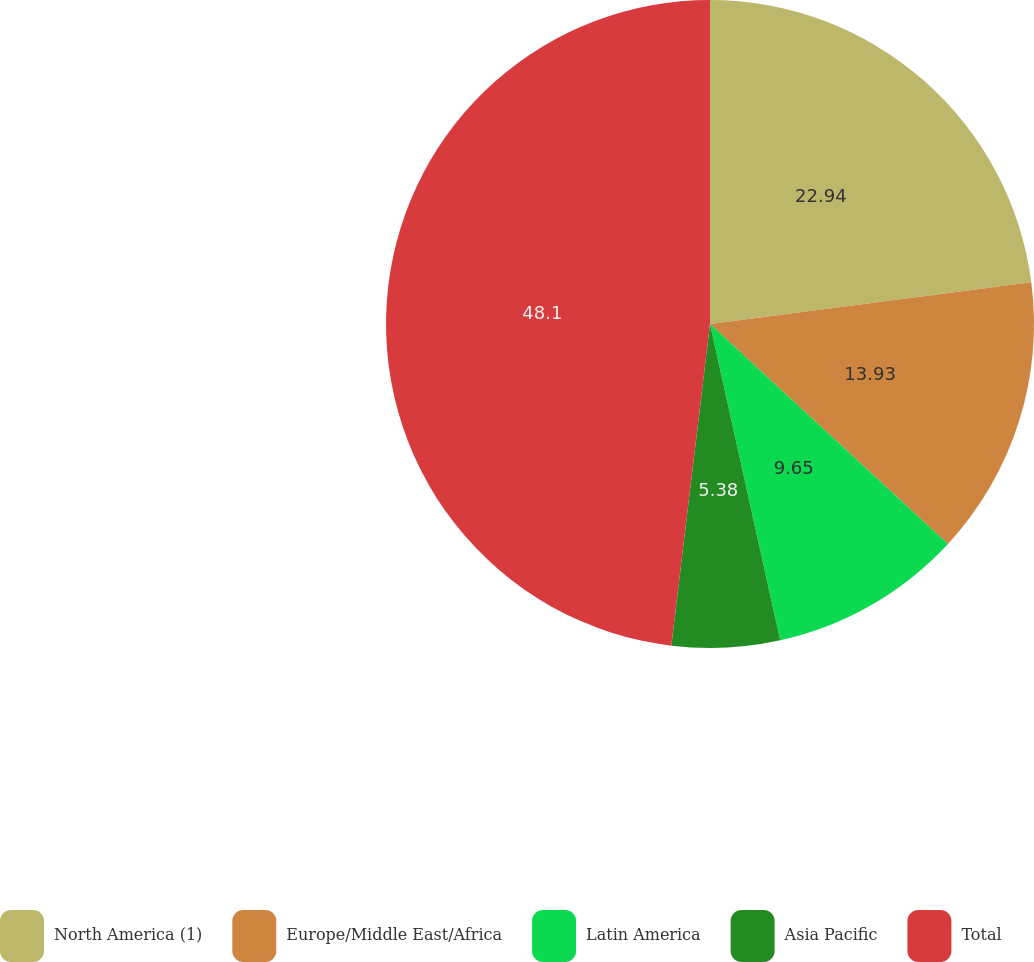Convert chart to OTSL. <chart><loc_0><loc_0><loc_500><loc_500><pie_chart><fcel>North America (1)<fcel>Europe/Middle East/Africa<fcel>Latin America<fcel>Asia Pacific<fcel>Total<nl><fcel>22.94%<fcel>13.93%<fcel>9.65%<fcel>5.38%<fcel>48.09%<nl></chart> 